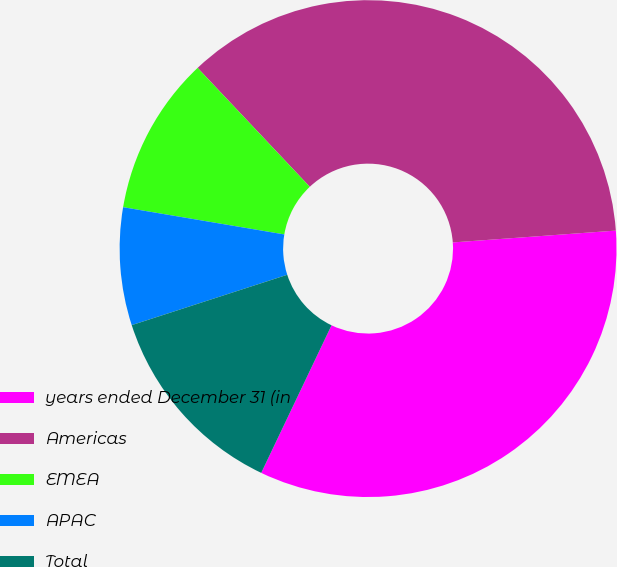Convert chart. <chart><loc_0><loc_0><loc_500><loc_500><pie_chart><fcel>years ended December 31 (in<fcel>Americas<fcel>EMEA<fcel>APAC<fcel>Total<nl><fcel>33.23%<fcel>35.88%<fcel>10.3%<fcel>7.65%<fcel>12.94%<nl></chart> 